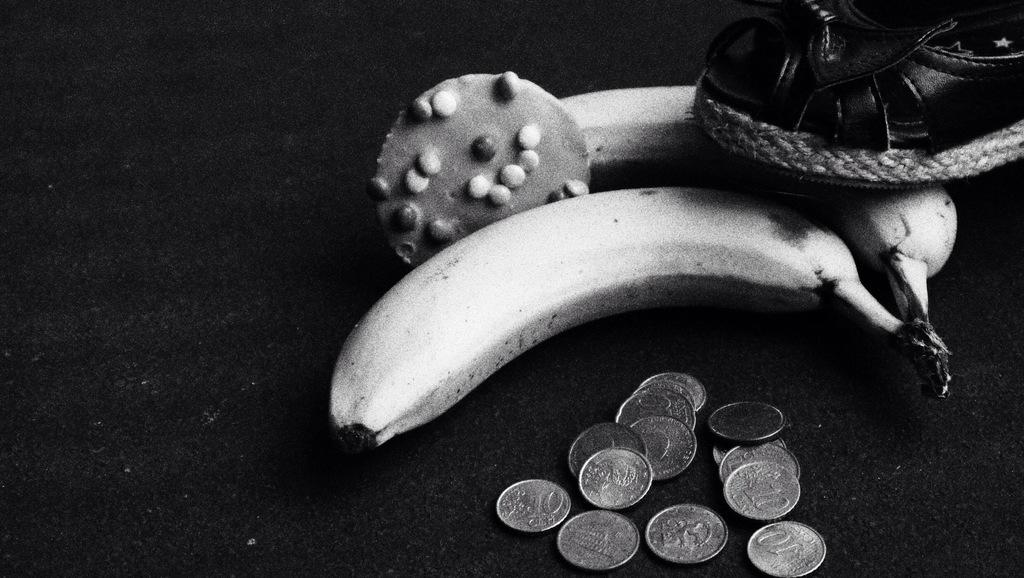What type of objects can be seen in the image? There are currency coins, a sandal, and two bananas in the image. Are there any other items visible in the image? Yes, there are other items placed on a table in the image. What color is the father's sweater in the image? There is no father or sweater present in the image. What type of alarm is going off in the image? There is no alarm present in the image. 